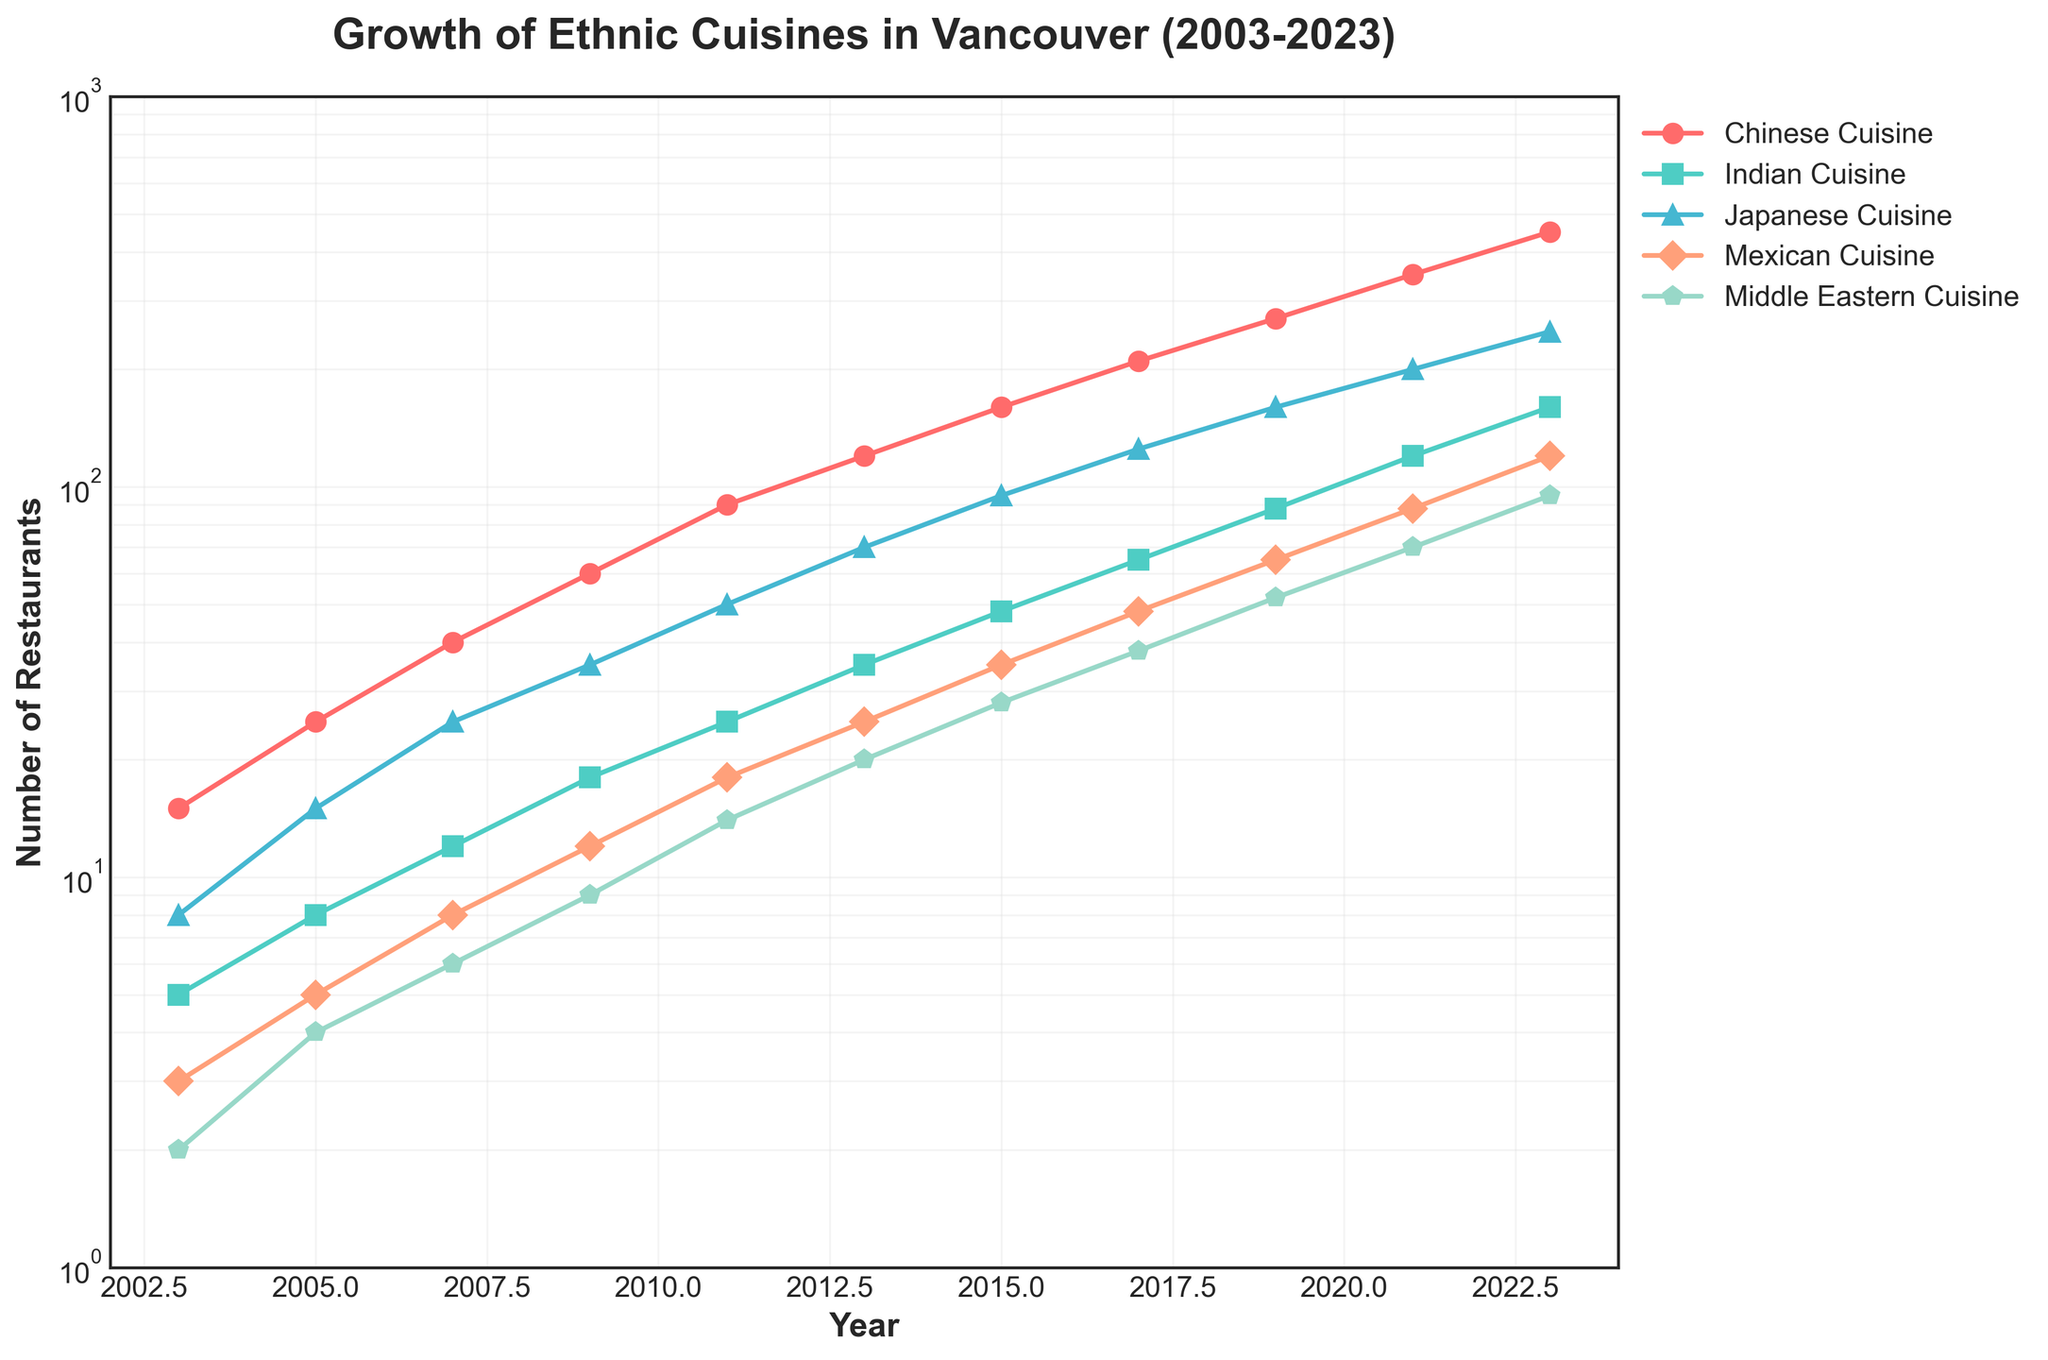What is the title of the figure? The title of the figure is located at the top and is generally large and bold to make it easily identifiable. In this figure, it reads "Growth of Ethnic Cuisines in Vancouver (2003-2023)."
Answer: Growth of Ethnic Cuisines in Vancouver (2003-2023) Which ethnic cuisine had the highest number of restaurants in 2023? By looking at the y-values on the log scale axis for the year 2023, we see that the Chinese Cuisine curve is the highest, indicating it had the most restaurants.
Answer: Chinese Cuisine How many data points are plotted for each ethnic cuisine on the figure? The number of data points can be seen by counting the markers along the curve of each cuisine. The data range from 2003 to 2023 with an increment of 2 years, resulting in 11 data points for each cuisine.
Answer: 11 Which ethnic cuisine saw the fastest growth between 2003 and 2023? To determine the fastest growth, we must look at the slope of each curve. The steeper the slope, the faster the growth. Chinese Cuisine has the steepest curve over the given period.
Answer: Chinese Cuisine Compare the number of Indian and Mexican Cuisine restaurants in 2015. Which had more? Refer to the y-axis values for Indian and Mexican Cuisine in 2015. The number of Indian Cuisine restaurants is 48, while Mexican Cuisine has 35. Hence, Indian Cuisine had more restaurants.
Answer: Indian Cuisine What was the trend for Middle Eastern Cuisine restaurants from 2003 to 2023? Observing the Middle Eastern Cuisine curve from 2003 to 2023, it shows a consistent upward trend, indicating growth in the number of these restaurants over the two decades.
Answer: Upward Growth How does the number of Japanese Cuisine restaurants in 2009 compare to those in 2021? From the figure, the number of Japanese Cuisine restaurants in 2009 is about 35, while in 2021 it is approximately 200. Thus, the number of restaurants increased significantly.
Answer: Increased significantly What is the general shape of the plot? The plot consists of multiple curves, each representing a different ethnic cuisine. The y-axis is on a logarithmic scale to better visualize the growth patterns, and the x-axis is linear spanning from 2003 to 2023.
Answer: Multiple curved lines on a log scale Which two cuisines had the smallest growth rate over the two decades? By comparing the slopes of all curves, the Middle Eastern and Mexican Cuisines have the least steep slopes, indicating the smallest growth rates in the number of restaurants.
Answer: Middle Eastern and Mexican Cuisines What is the approximate number of Chinese Cuisine restaurants in 2011? Locate the 2011 marker on the Chinese Cuisine curve and match it to the y-axis value. There are roughly 90 Chinese Cuisine restaurants in 2011.
Answer: 90 